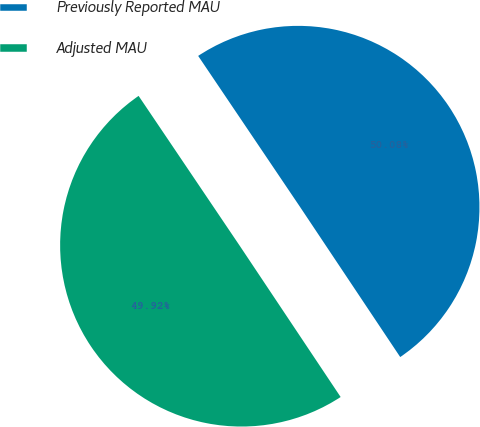Convert chart to OTSL. <chart><loc_0><loc_0><loc_500><loc_500><pie_chart><fcel>Previously Reported MAU<fcel>Adjusted MAU<nl><fcel>50.08%<fcel>49.92%<nl></chart> 